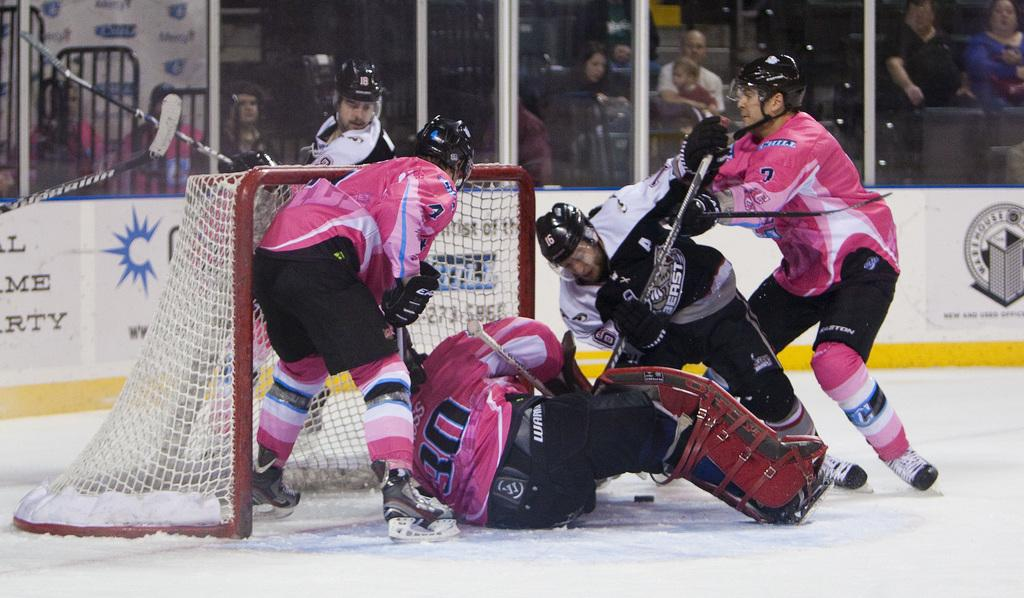<image>
Relay a brief, clear account of the picture shown. Player 30 slides into the goal net as the opposition tries to keep them out. 